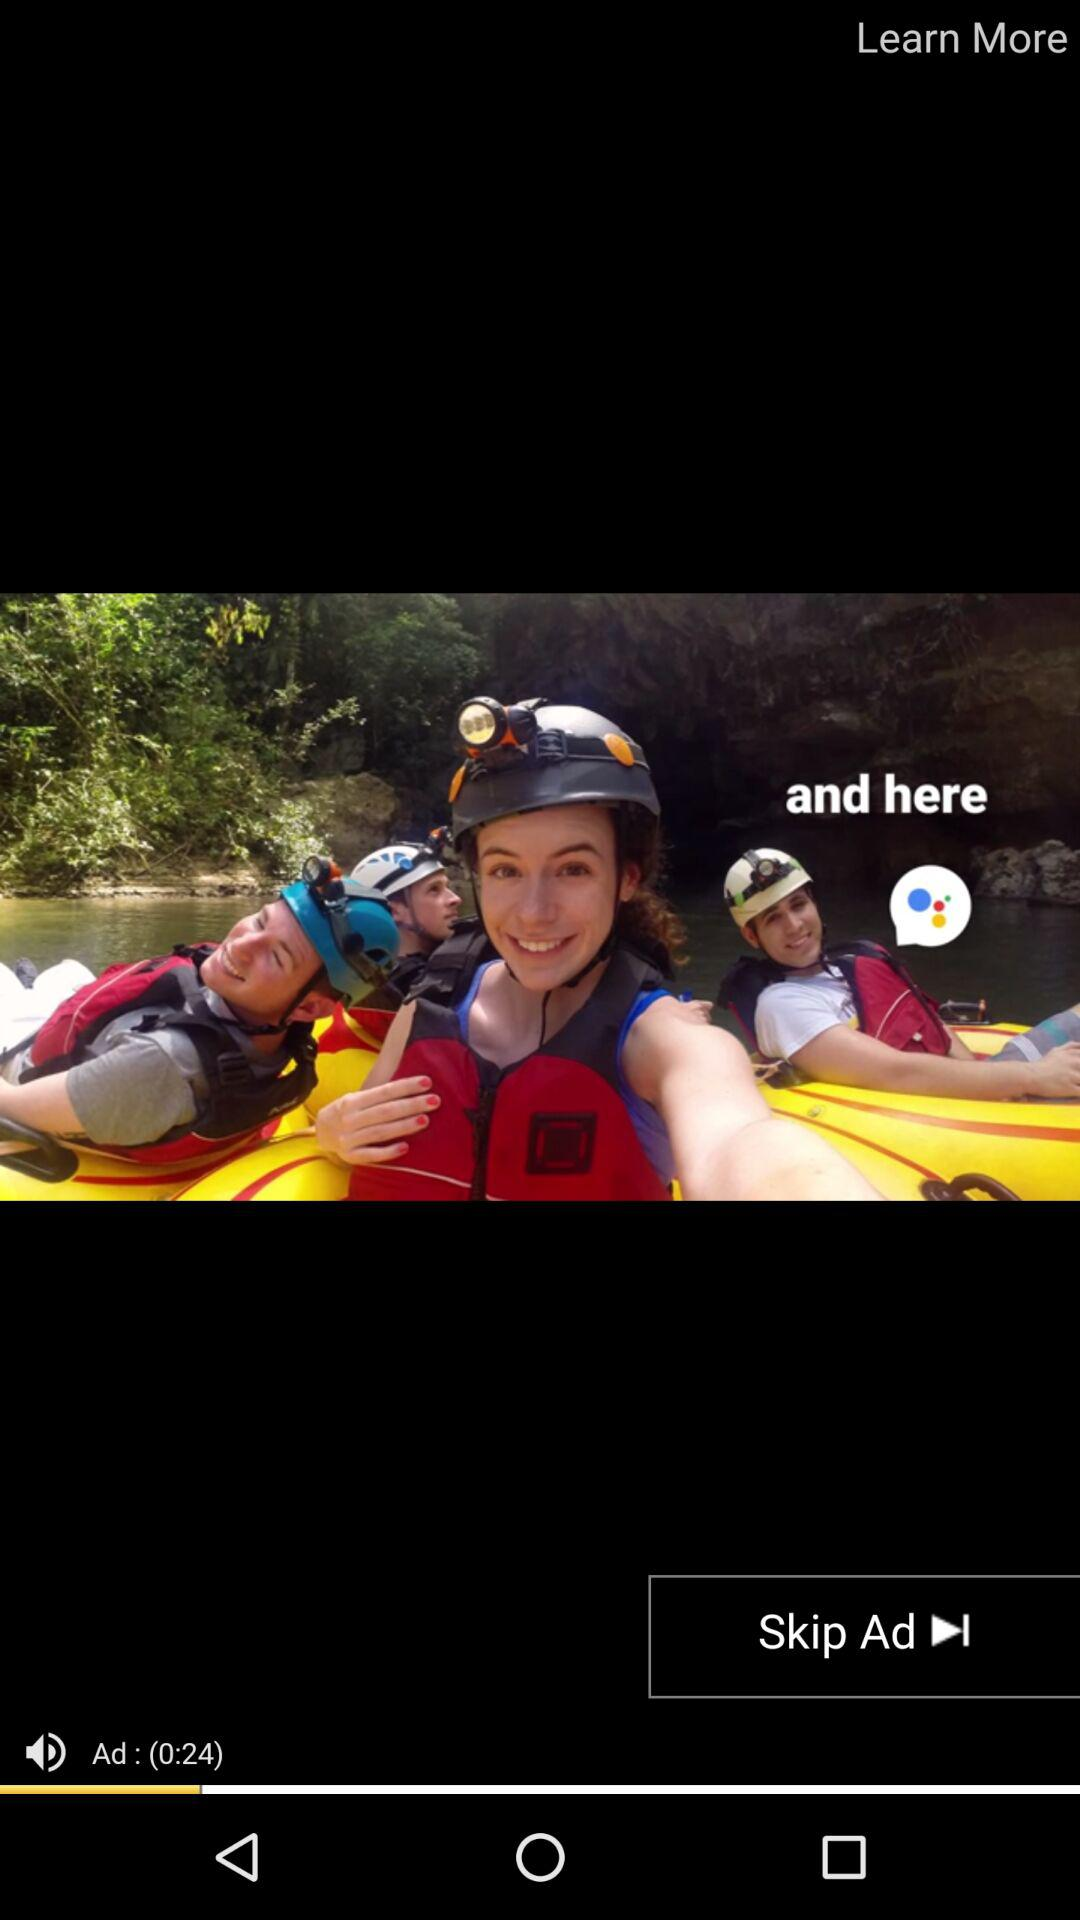How many seconds long is the ad?
Answer the question using a single word or phrase. 24 